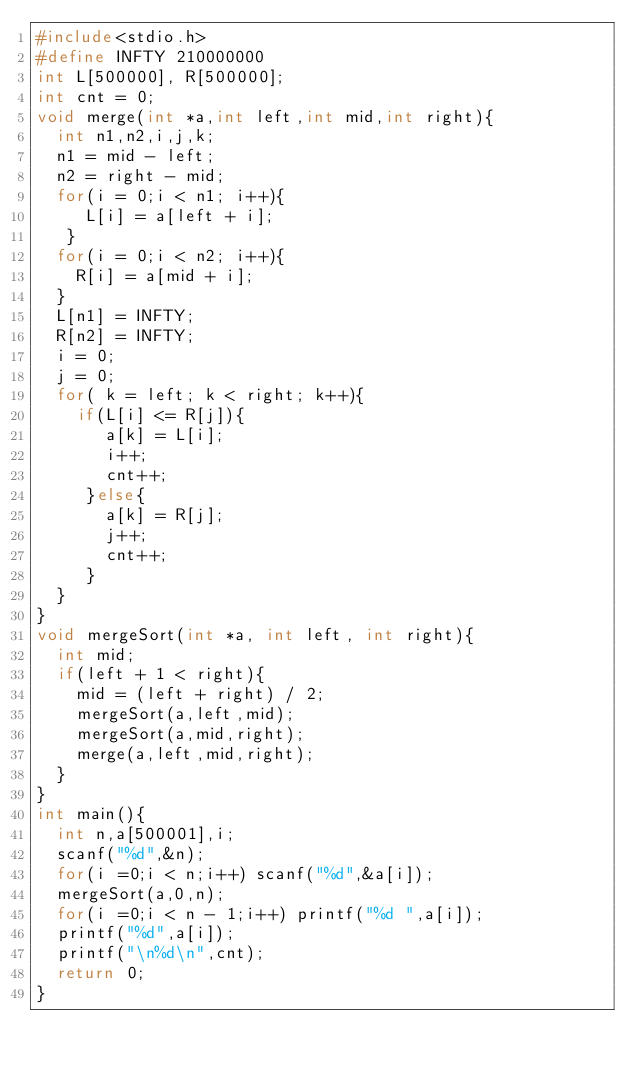<code> <loc_0><loc_0><loc_500><loc_500><_C_>#include<stdio.h>
#define INFTY 210000000
int L[500000], R[500000];
int cnt = 0;
void merge(int *a,int left,int mid,int right){
  int n1,n2,i,j,k;
  n1 = mid - left;
  n2 = right - mid;
  for(i = 0;i < n1; i++){
     L[i] = a[left + i];
   }
  for(i = 0;i < n2; i++){
    R[i] = a[mid + i];
  }
  L[n1] = INFTY;
  R[n2] = INFTY;
  i = 0;
  j = 0;
  for( k = left; k < right; k++){
    if(L[i] <= R[j]){
       a[k] = L[i];
       i++;
       cnt++;
     }else{
       a[k] = R[j];
       j++;
       cnt++;
     }
  }
}
void mergeSort(int *a, int left, int right){
  int mid;
  if(left + 1 < right){
    mid = (left + right) / 2;
    mergeSort(a,left,mid);
    mergeSort(a,mid,right);
    merge(a,left,mid,right);
  }
}
int main(){
  int n,a[500001],i;
  scanf("%d",&n);
  for(i =0;i < n;i++) scanf("%d",&a[i]);
  mergeSort(a,0,n);
  for(i =0;i < n - 1;i++) printf("%d ",a[i]);
  printf("%d",a[i]);
  printf("\n%d\n",cnt);
  return 0;
}

</code> 